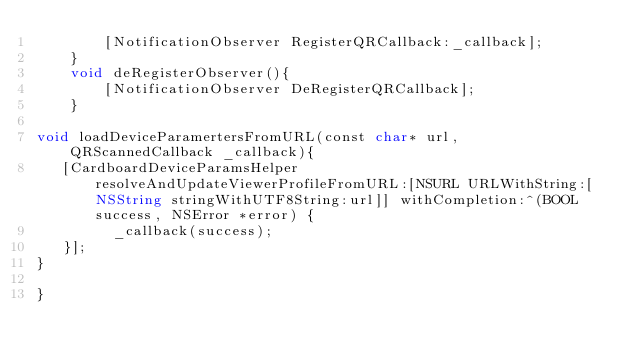<code> <loc_0><loc_0><loc_500><loc_500><_ObjectiveC_>        [NotificationObserver RegisterQRCallback:_callback];
    }
    void deRegisterObserver(){
        [NotificationObserver DeRegisterQRCallback];
    }

void loadDeviceParamertersFromURL(const char* url, QRScannedCallback _callback){
   [CardboardDeviceParamsHelper resolveAndUpdateViewerProfileFromURL:[NSURL URLWithString:[NSString stringWithUTF8String:url]] withCompletion:^(BOOL success, NSError *error) {
         _callback(success);
   }];
}

}
</code> 